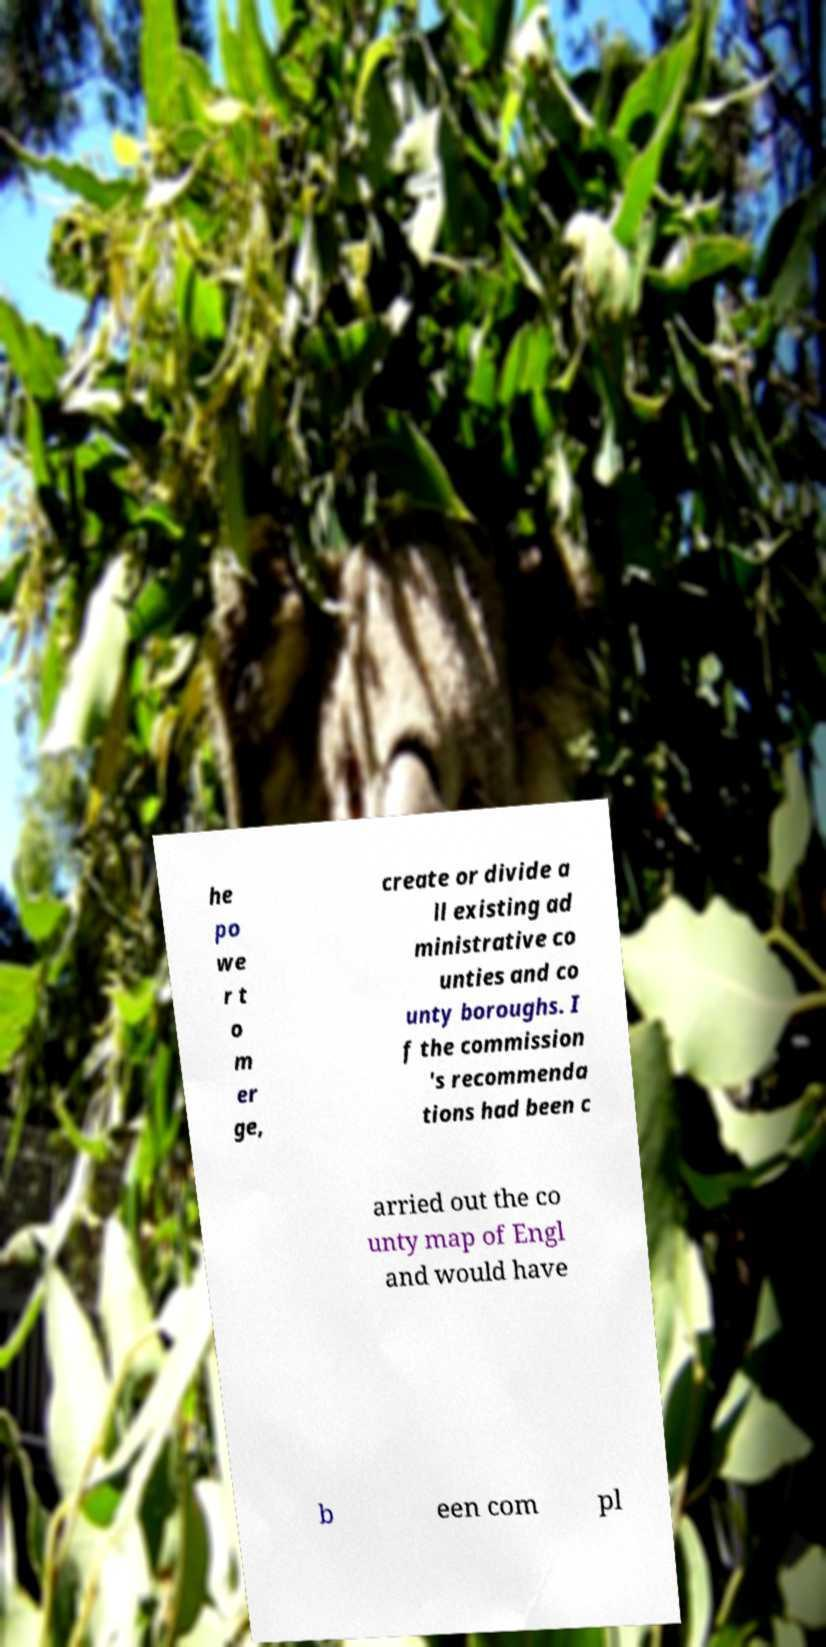Please identify and transcribe the text found in this image. he po we r t o m er ge, create or divide a ll existing ad ministrative co unties and co unty boroughs. I f the commission 's recommenda tions had been c arried out the co unty map of Engl and would have b een com pl 